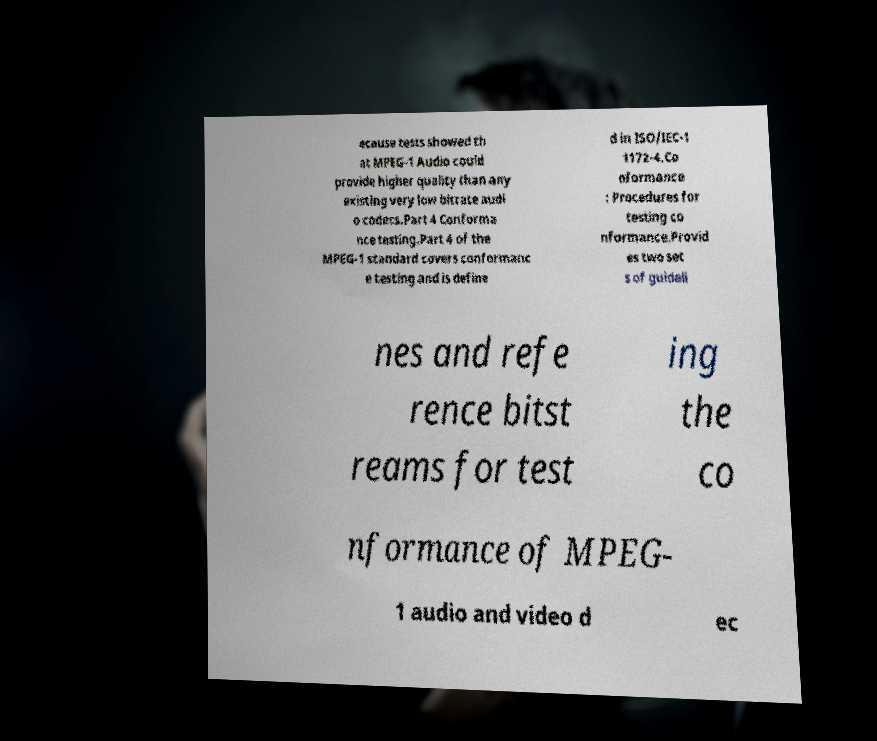There's text embedded in this image that I need extracted. Can you transcribe it verbatim? ecause tests showed th at MPEG-1 Audio could provide higher quality than any existing very low bitrate audi o codecs.Part 4 Conforma nce testing.Part 4 of the MPEG-1 standard covers conformanc e testing and is define d in ISO/IEC-1 1172-4.Co nformance : Procedures for testing co nformance.Provid es two set s of guideli nes and refe rence bitst reams for test ing the co nformance of MPEG- 1 audio and video d ec 